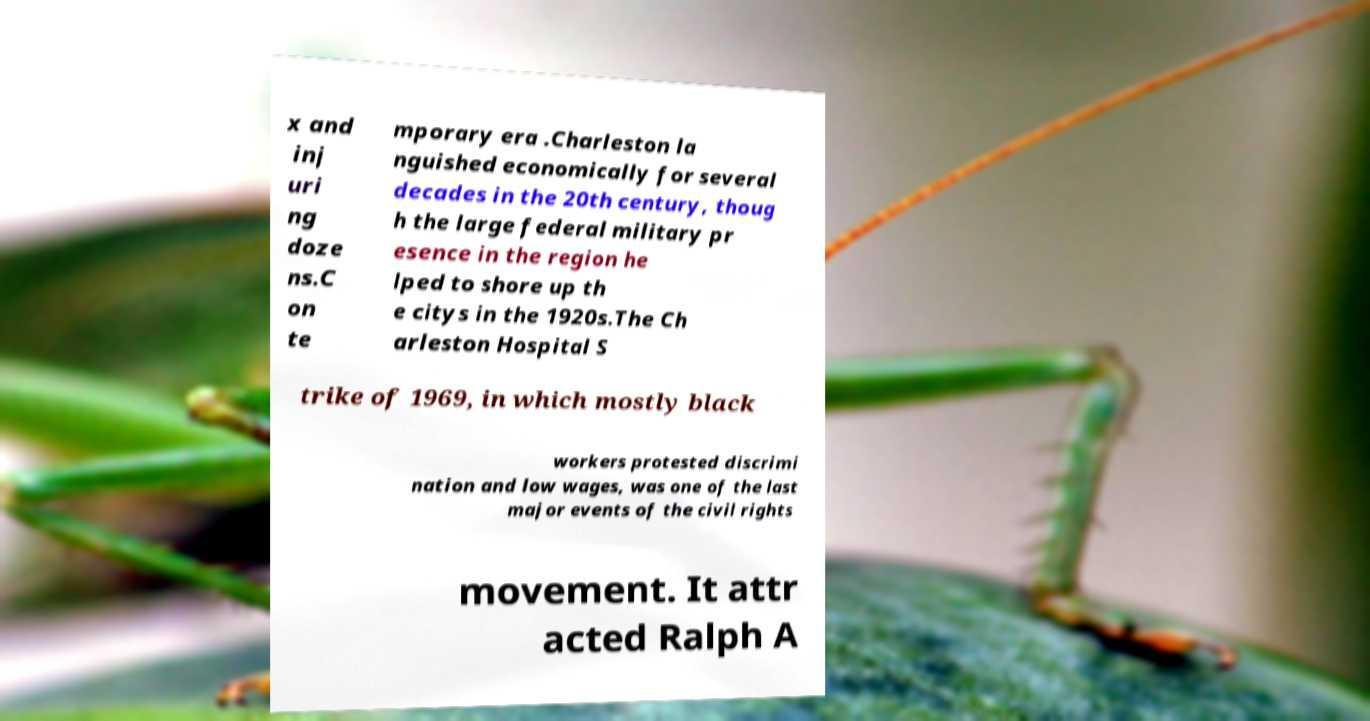Please read and relay the text visible in this image. What does it say? x and inj uri ng doze ns.C on te mporary era .Charleston la nguished economically for several decades in the 20th century, thoug h the large federal military pr esence in the region he lped to shore up th e citys in the 1920s.The Ch arleston Hospital S trike of 1969, in which mostly black workers protested discrimi nation and low wages, was one of the last major events of the civil rights movement. It attr acted Ralph A 